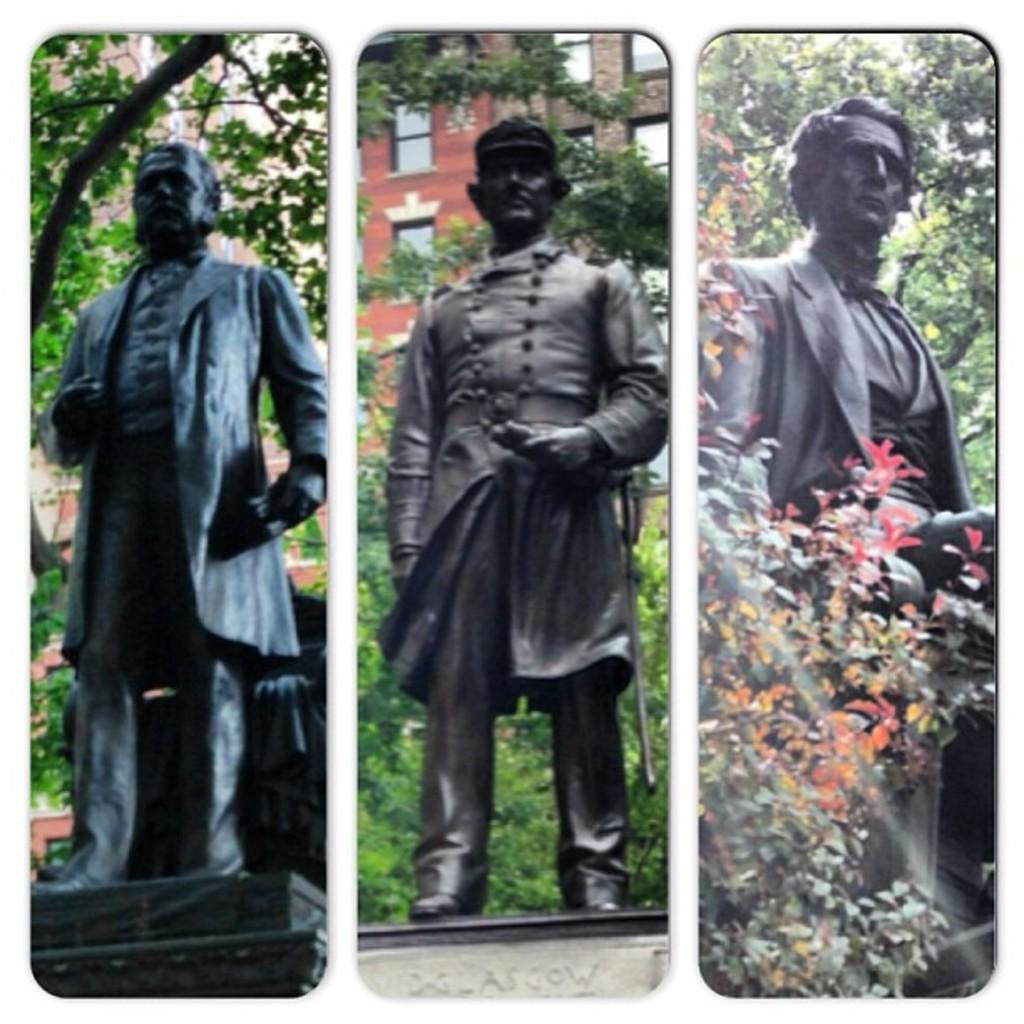What is the main subject of the image? The main subject of the image is a photo collage of three different persons' statues. What can be seen in the background of the image? There are trees and buildings visible in the background. What type of nose can be seen on the pickle in the image? There is no pickle present in the image, and therefore no nose can be observed on it. 